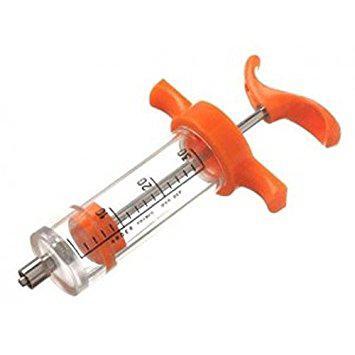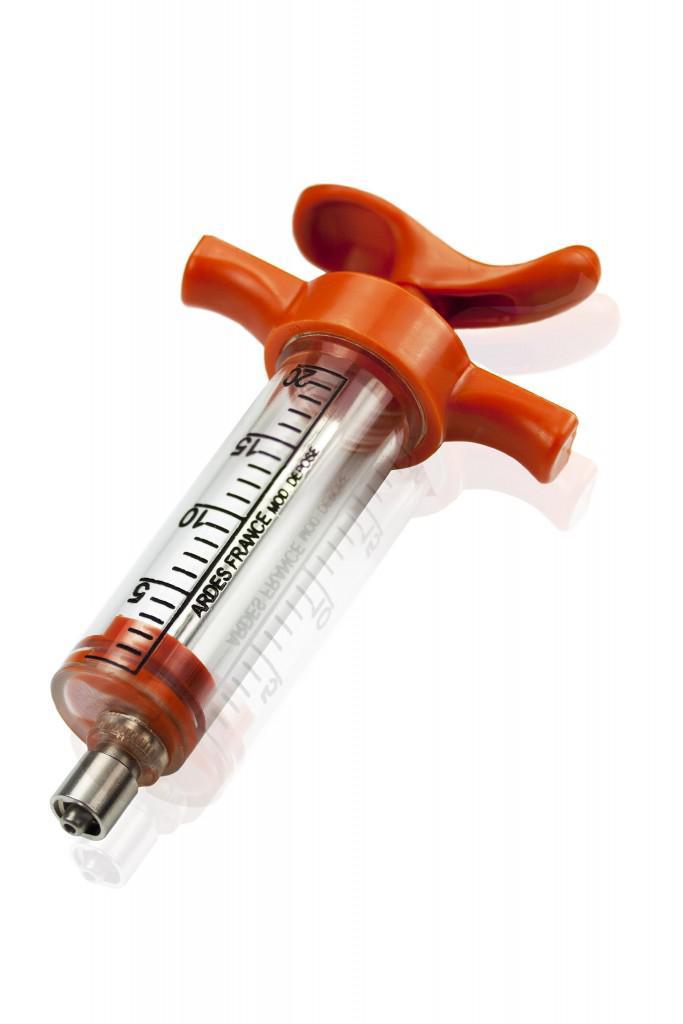The first image is the image on the left, the second image is the image on the right. Considering the images on both sides, is "There are two orange colored syringes." valid? Answer yes or no. Yes. The first image is the image on the left, the second image is the image on the right. Analyze the images presented: Is the assertion "Each of the syringes has an orange plunger." valid? Answer yes or no. Yes. 